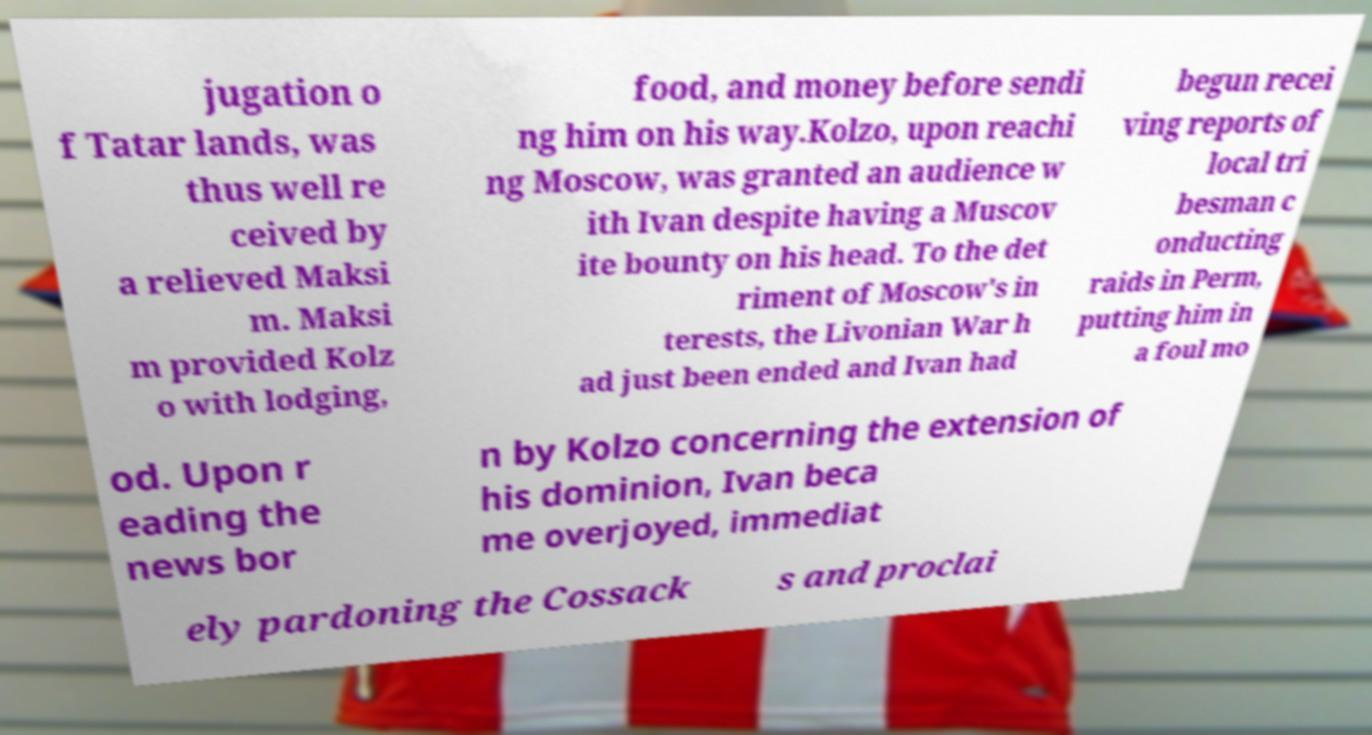What messages or text are displayed in this image? I need them in a readable, typed format. jugation o f Tatar lands, was thus well re ceived by a relieved Maksi m. Maksi m provided Kolz o with lodging, food, and money before sendi ng him on his way.Kolzo, upon reachi ng Moscow, was granted an audience w ith Ivan despite having a Muscov ite bounty on his head. To the det riment of Moscow's in terests, the Livonian War h ad just been ended and Ivan had begun recei ving reports of local tri besman c onducting raids in Perm, putting him in a foul mo od. Upon r eading the news bor n by Kolzo concerning the extension of his dominion, Ivan beca me overjoyed, immediat ely pardoning the Cossack s and proclai 